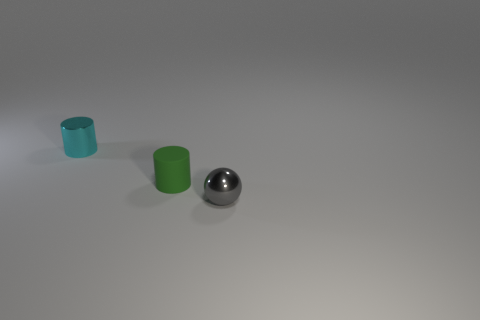What number of green matte objects are there?
Give a very brief answer. 1. How many small metal things are to the left of the small ball?
Provide a succinct answer. 1. Is there a small cyan metal thing of the same shape as the green thing?
Give a very brief answer. Yes. Are the cylinder behind the tiny green rubber thing and the small thing right of the green rubber thing made of the same material?
Provide a succinct answer. Yes. What size is the cylinder right of the metal object behind the small metal object in front of the cyan cylinder?
Offer a terse response. Small. What material is the green thing that is the same size as the gray object?
Provide a succinct answer. Rubber. Is there a yellow metal thing of the same size as the cyan metal cylinder?
Offer a very short reply. No. Is the green object the same shape as the small cyan metal object?
Your answer should be very brief. Yes. Is there a green rubber thing that is left of the small metal object in front of the tiny metal object that is behind the small gray object?
Your answer should be compact. Yes. How many other things are the same color as the small ball?
Your answer should be compact. 0. 